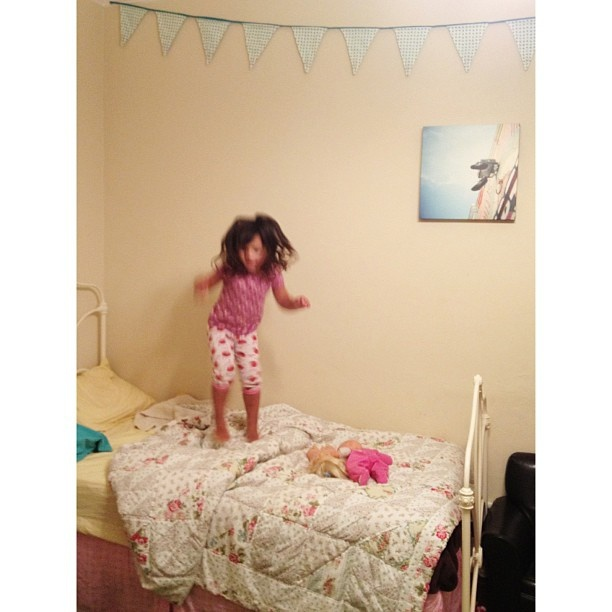Describe the objects in this image and their specific colors. I can see bed in white, tan, and gray tones and people in white, brown, lightpink, black, and maroon tones in this image. 